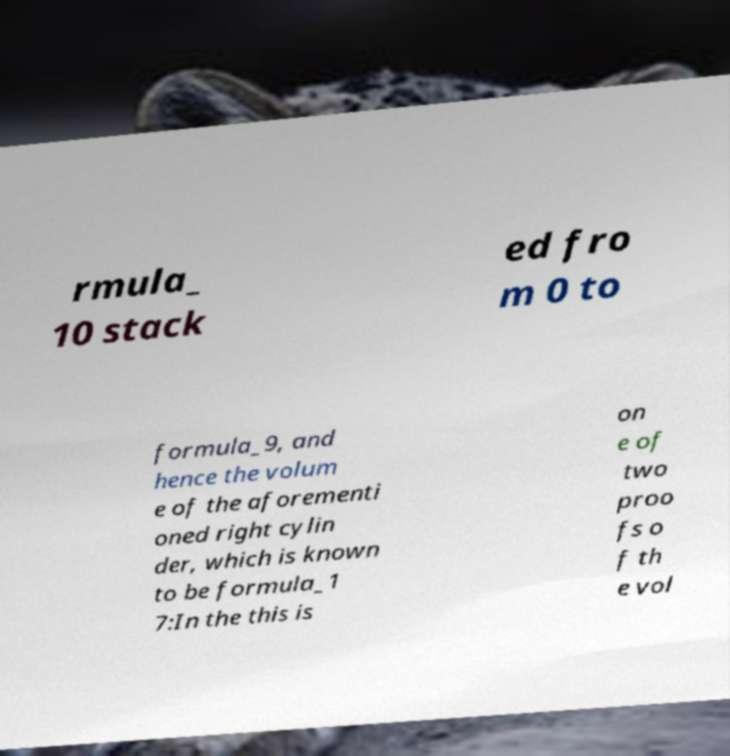I need the written content from this picture converted into text. Can you do that? rmula_ 10 stack ed fro m 0 to formula_9, and hence the volum e of the aforementi oned right cylin der, which is known to be formula_1 7:In the this is on e of two proo fs o f th e vol 